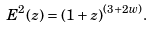Convert formula to latex. <formula><loc_0><loc_0><loc_500><loc_500>E ^ { 2 } ( z ) = ( 1 + z ) ^ { ( 3 + 2 w ) } .</formula> 